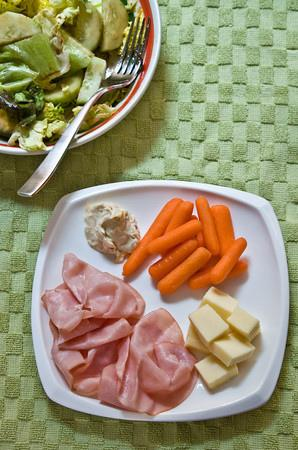Which corner of the plate contains meat? Please explain your reasoning. bottom left. A white rectangular plate has different kinds of food on it. there is some pink ham on one corner of plate. 